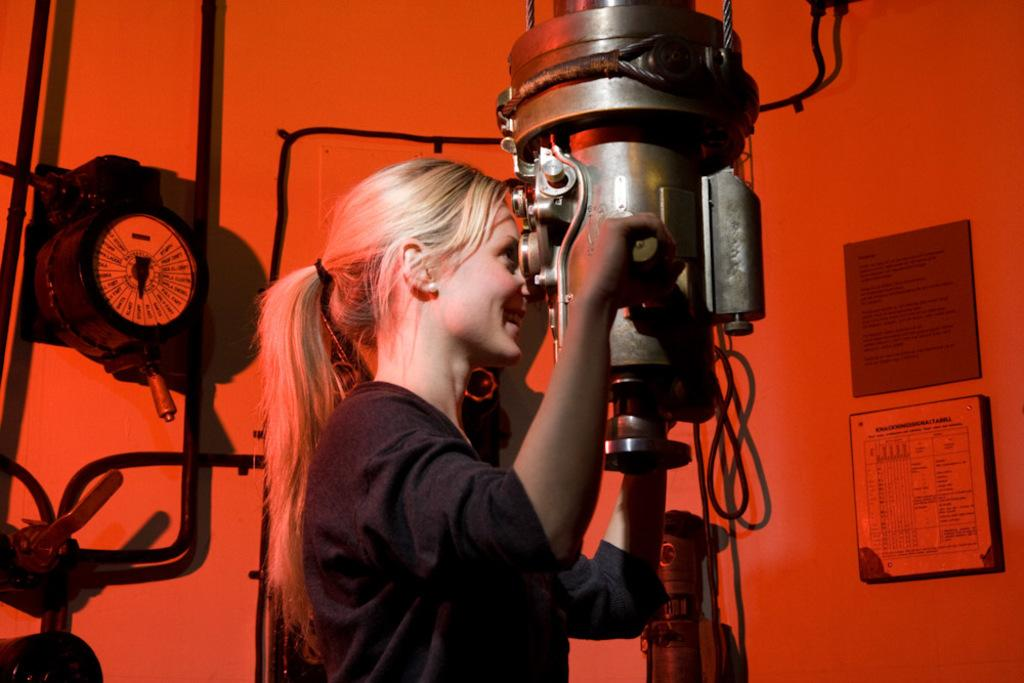What type of structure can be seen in the image? There is a wall in the image. What is hanging on the wall? There is a photo frame in the image. Can you describe the woman in the image? There is a woman wearing a black dress in the image. What type of object is present that uses electricity? There is an electrical equipment in the image. Is there a snake slithering through the yard in the image? There is no yard or snake present in the image. Is the woman in the image being held in a jail cell? There is no jail or jail cell present in the image; it features a woman wearing a black dress in front of a wall with a photo frame and electrical equipment. 